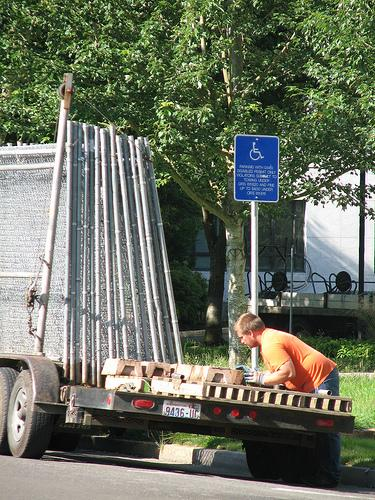Point out any objects or materials that are being transported in the trailer. Fencing material, metal lawn chairs, cement blocks, and a yellow wooden pallet are all being transported in the trailer. Mention any distinguishing features of the back lights on the trailer. There are six visible lights on the back of the trailer in the image. Explain the man's attire, specifically focusing on the color of his shirt and what he has on his hands. The man is wearing a bright orange shirt and has gloves on his hands. Identify the primary activity taking place in the image and the main participant. A man wearing an orange shirt is breaking down and loading a fence onto a trailer. Provide information about the curb in the image, including its location and any relevant characteristics. There is a curb on the side of the street which appears to be part of a road. Mention the type of license plate present in the image and its location. A red, white, and blue State of Louisiana license plate is located on a trailer. What type of tree is visible in the image and where is it situated? A large green shade tree is present in the yard close to the image's edge. What type of sign is visible in the image and what color is it? There is a blue handicapped parking sign in the image. Identify the items placed on top of the pallets in the image. Cinder blocks are placed on top of the pallets in the image. Describe the fence sections in the image and where they are placed. Sections of chainlink fence are stacked on the back of a trailer, with metal poles placed next to them. Look for the little girl with a pink balloon standing behind the man wearing gloves. No, it's not mentioned in the image. 